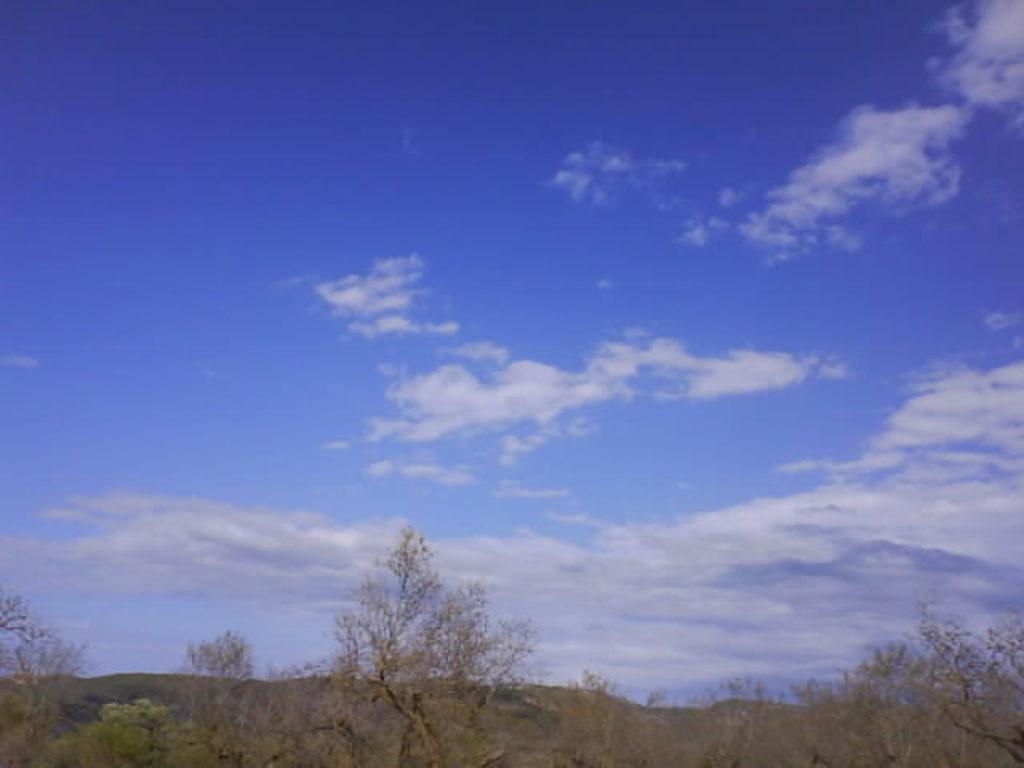Describe this image in one or two sentences. In this image I can see few trees and in the background I can see the sky. 